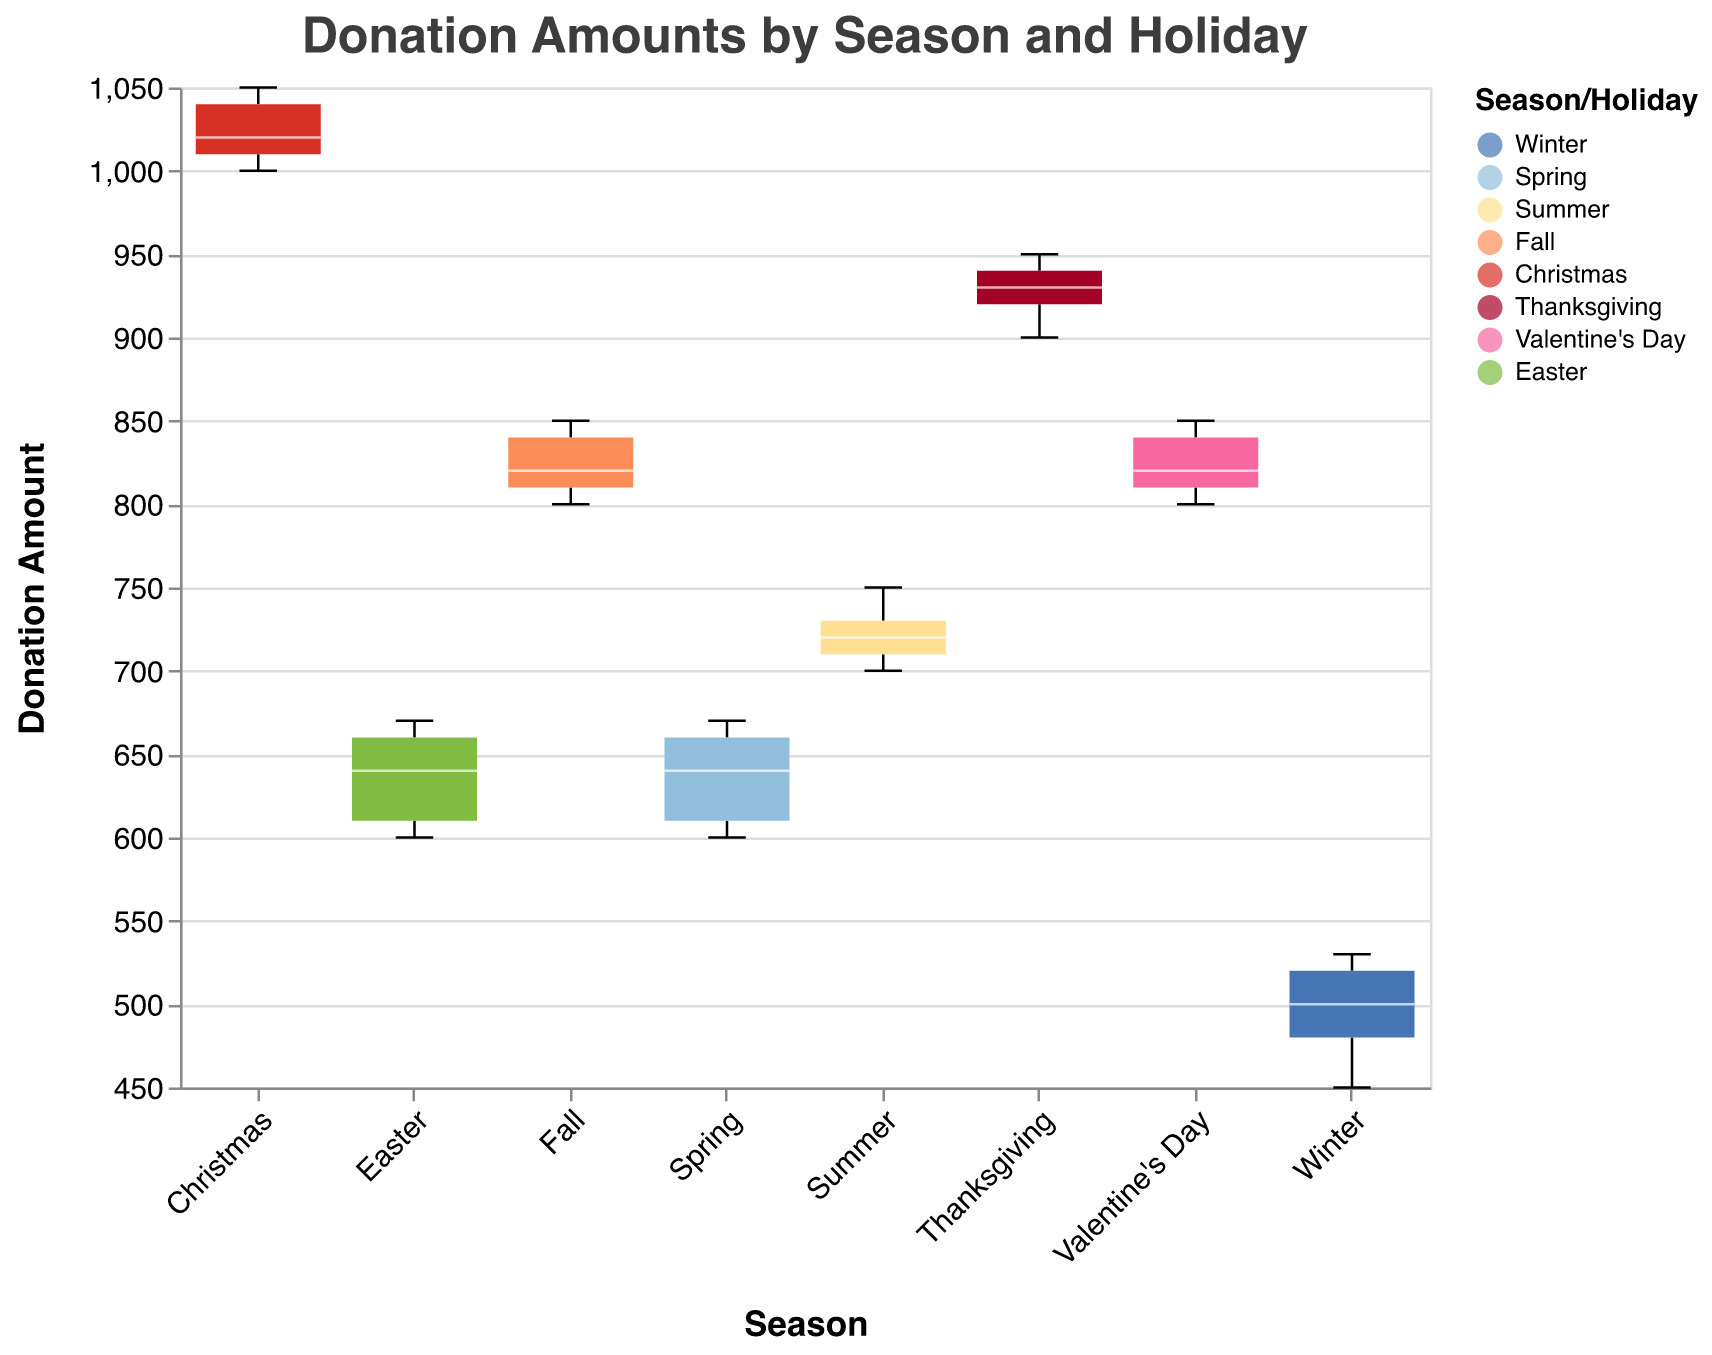what is the title of the figure? The title of the figure is displayed at the top of the figure. It reads, "Donation Amounts by Season and Holiday," indicating the purpose and content of the box plot
Answer: Donation Amounts by Season and Holiday What season or holiday has the highest median donation amount? The median donation amount is shown by the white line within each box in a box plot. The box plot for Christmas has the highest median, indicating Christmas has the highest median donation amount
Answer: Christmas Which seasons or holidays have an equal range of donation amounts? In a notched box plot, the range is indicated by the extent of the whiskers. Valentine's Day and Fall have whiskers that cover the same vertical span from just above 800 to just below 850, indicating they have an equal range of donation amounts
Answer: Valentine's Day and Fall What is the interquartile range (IQR) for the Winter season? The IQR is the range between the first quartile (Q1) and the third quartile (Q3) within the box. For Winter, IQR = Q3 - Q1. The box extends from around 450 (Q1) to about 520 (Q3), calculating IQR as 520 - 450
Answer: 70 Compare the median donation amounts between Summer and Winter. Which is higher and by how much? The median donation is indicated by the white line inside each box. For Summer, it's around 720, and for Winter, it's around 500. The difference between them is 720 - 500
Answer: Summer, by 220 Which season has the smallest variability in donation amounts and how is it determined? The variability is often assessed by the IQR or the length of the box within the plot. The season with the smallest box length has the least variability. Winter has the smallest box length, indicating the smallest variability
Answer: Winter Is there any season or holiday with outliers? In a box plot, outliers are typically shown as individual points outside the whiskers. Observing the figure, there are no individual points outside the whiskers, indicating there are no outliers
Answer: No During which season do donations range between 600 and 670? Observing the ranges indicated by the whiskers and boxes, Spring is the season where donations spread between 600 and 670
Answer: Spring What is the difference in the maximum donation amounts for Thanksgiving and Easter? The maximum is indicated by the top whisker. For Thanksgiving, the maximum is around 950, and for Easter, it is around 670. The difference is 950 - 670
Answer: 280 How does the width of the notches for Christmas compare to that of Thanksgiving? The width of the notches indicates the confidence interval around the median. For Christmas, the notches are narrower compared to those for Thanksgiving, indicating a smaller spread around the median
Answer: Christmas notches are narrower 